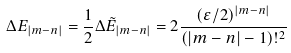Convert formula to latex. <formula><loc_0><loc_0><loc_500><loc_500>\Delta E _ { | m - n | } = \frac { 1 } { 2 } \Delta \tilde { E } _ { | m - n | } = 2 \frac { ( \varepsilon / 2 ) ^ { | m - n | } } { ( | m - n | - 1 ) ! ^ { 2 } }</formula> 